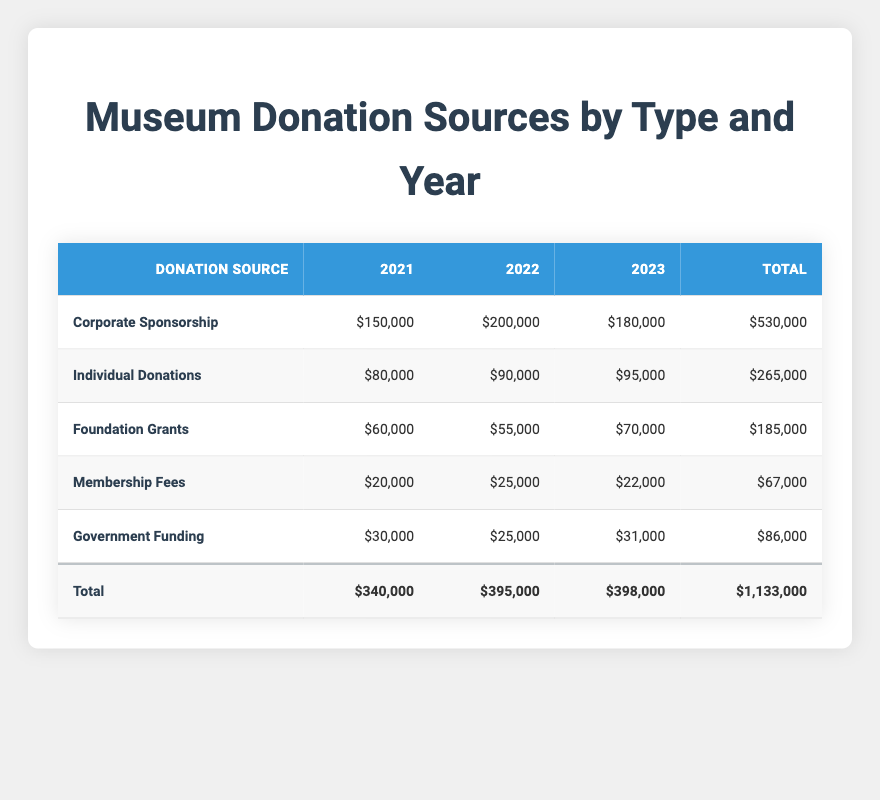What was the total amount received from Individual Donations in 2022? By looking at the table, the amount received from Individual Donations in 2022 is directly listed under that category in the respective year column. The total is 90,000.
Answer: 90,000 Which donation source had the highest total amount over the three years? To determine this, I need to compare the total amounts for each donation source listed at the bottom of the table. Corporate Sponsorship has a total of 530,000, which is higher than the others.
Answer: Corporate Sponsorship Was there any increase in Membership Fees from 2021 to 2023? I should look at the values for Membership Fees in both years. In 2021, the amount is 20,000, and in 2023 it is 22,000. Since 22,000 is greater than 20,000, there was an increase.
Answer: Yes What is the average amount received from Foundation Grants over the three years? First, I sum the amounts received from Foundation Grants: 60,000 + 55,000 + 70,000 = 185,000. Then, I divide this total by the number of years, which is 3. So, the average is 185,000 / 3 = 61,666.67.
Answer: 61,666.67 Is the total amount from Government Funding higher than that from Membership Fees? The total for Government Funding is 86,000 and for Membership Fees, it is 67,000. Since 86,000 is greater than 67,000, the statement is true.
Answer: Yes What was the percentage increase in Corporate Sponsorship from 2021 to 2022? I find the difference between the amounts for Corporate Sponsorship in 2022 (200,000) and 2021 (150,000), which is 50,000. Next, I divide this difference by the 2021 amount and multiply by 100: (50,000 / 150,000) * 100 = 33.33%.
Answer: 33.33% 